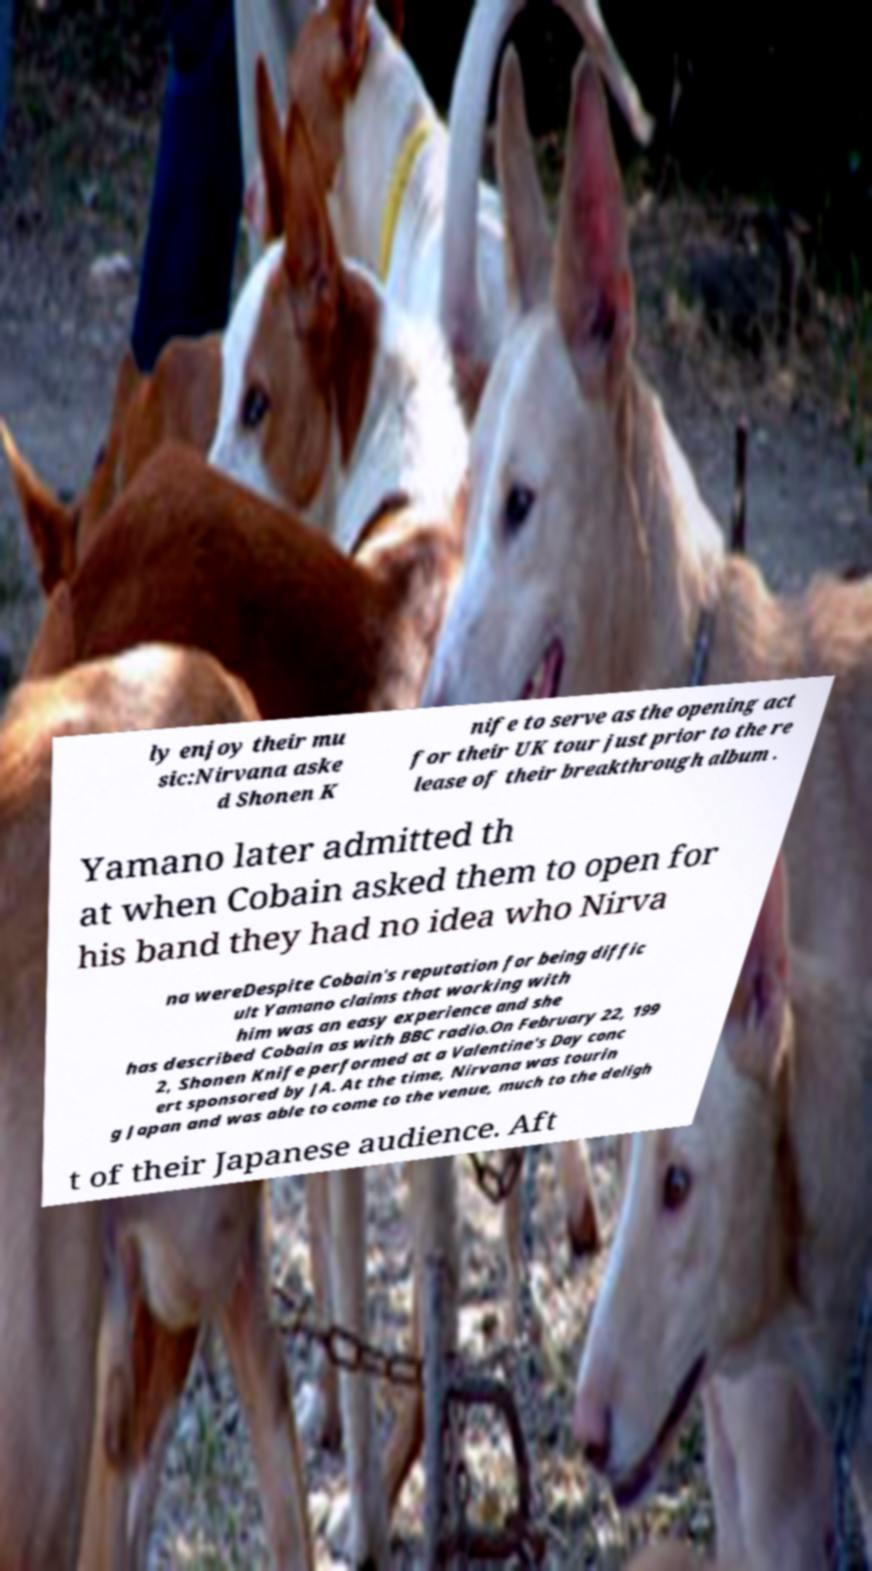Please identify and transcribe the text found in this image. ly enjoy their mu sic:Nirvana aske d Shonen K nife to serve as the opening act for their UK tour just prior to the re lease of their breakthrough album . Yamano later admitted th at when Cobain asked them to open for his band they had no idea who Nirva na wereDespite Cobain's reputation for being diffic ult Yamano claims that working with him was an easy experience and she has described Cobain as with BBC radio.On February 22, 199 2, Shonen Knife performed at a Valentine's Day conc ert sponsored by JA. At the time, Nirvana was tourin g Japan and was able to come to the venue, much to the deligh t of their Japanese audience. Aft 